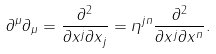Convert formula to latex. <formula><loc_0><loc_0><loc_500><loc_500>\partial ^ { \mu } \partial _ { \mu } = \frac { \partial ^ { 2 } } { \partial x ^ { j } \partial x _ { j } } = \eta ^ { j n } \frac { \partial ^ { 2 } } { \partial x ^ { j } \partial x ^ { n } } .</formula> 